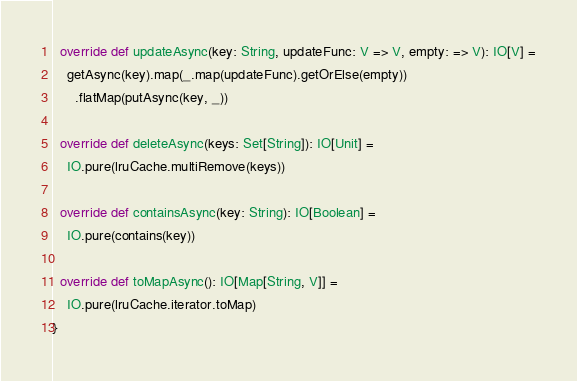<code> <loc_0><loc_0><loc_500><loc_500><_Scala_>
  override def updateAsync(key: String, updateFunc: V => V, empty: => V): IO[V] =
    getAsync(key).map(_.map(updateFunc).getOrElse(empty))
      .flatMap(putAsync(key, _))

  override def deleteAsync(keys: Set[String]): IO[Unit] =
    IO.pure(lruCache.multiRemove(keys))

  override def containsAsync(key: String): IO[Boolean] =
    IO.pure(contains(key))

  override def toMapAsync(): IO[Map[String, V]] =
    IO.pure(lruCache.iterator.toMap)
}
</code> 